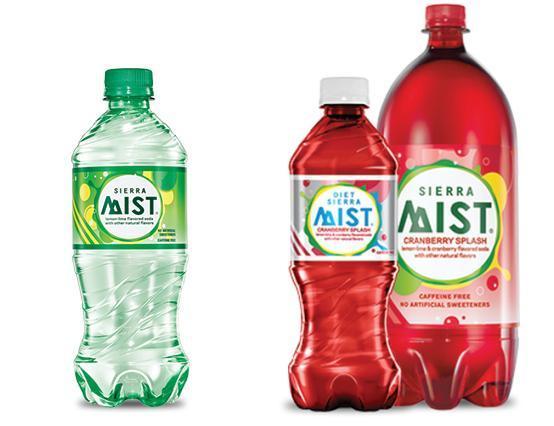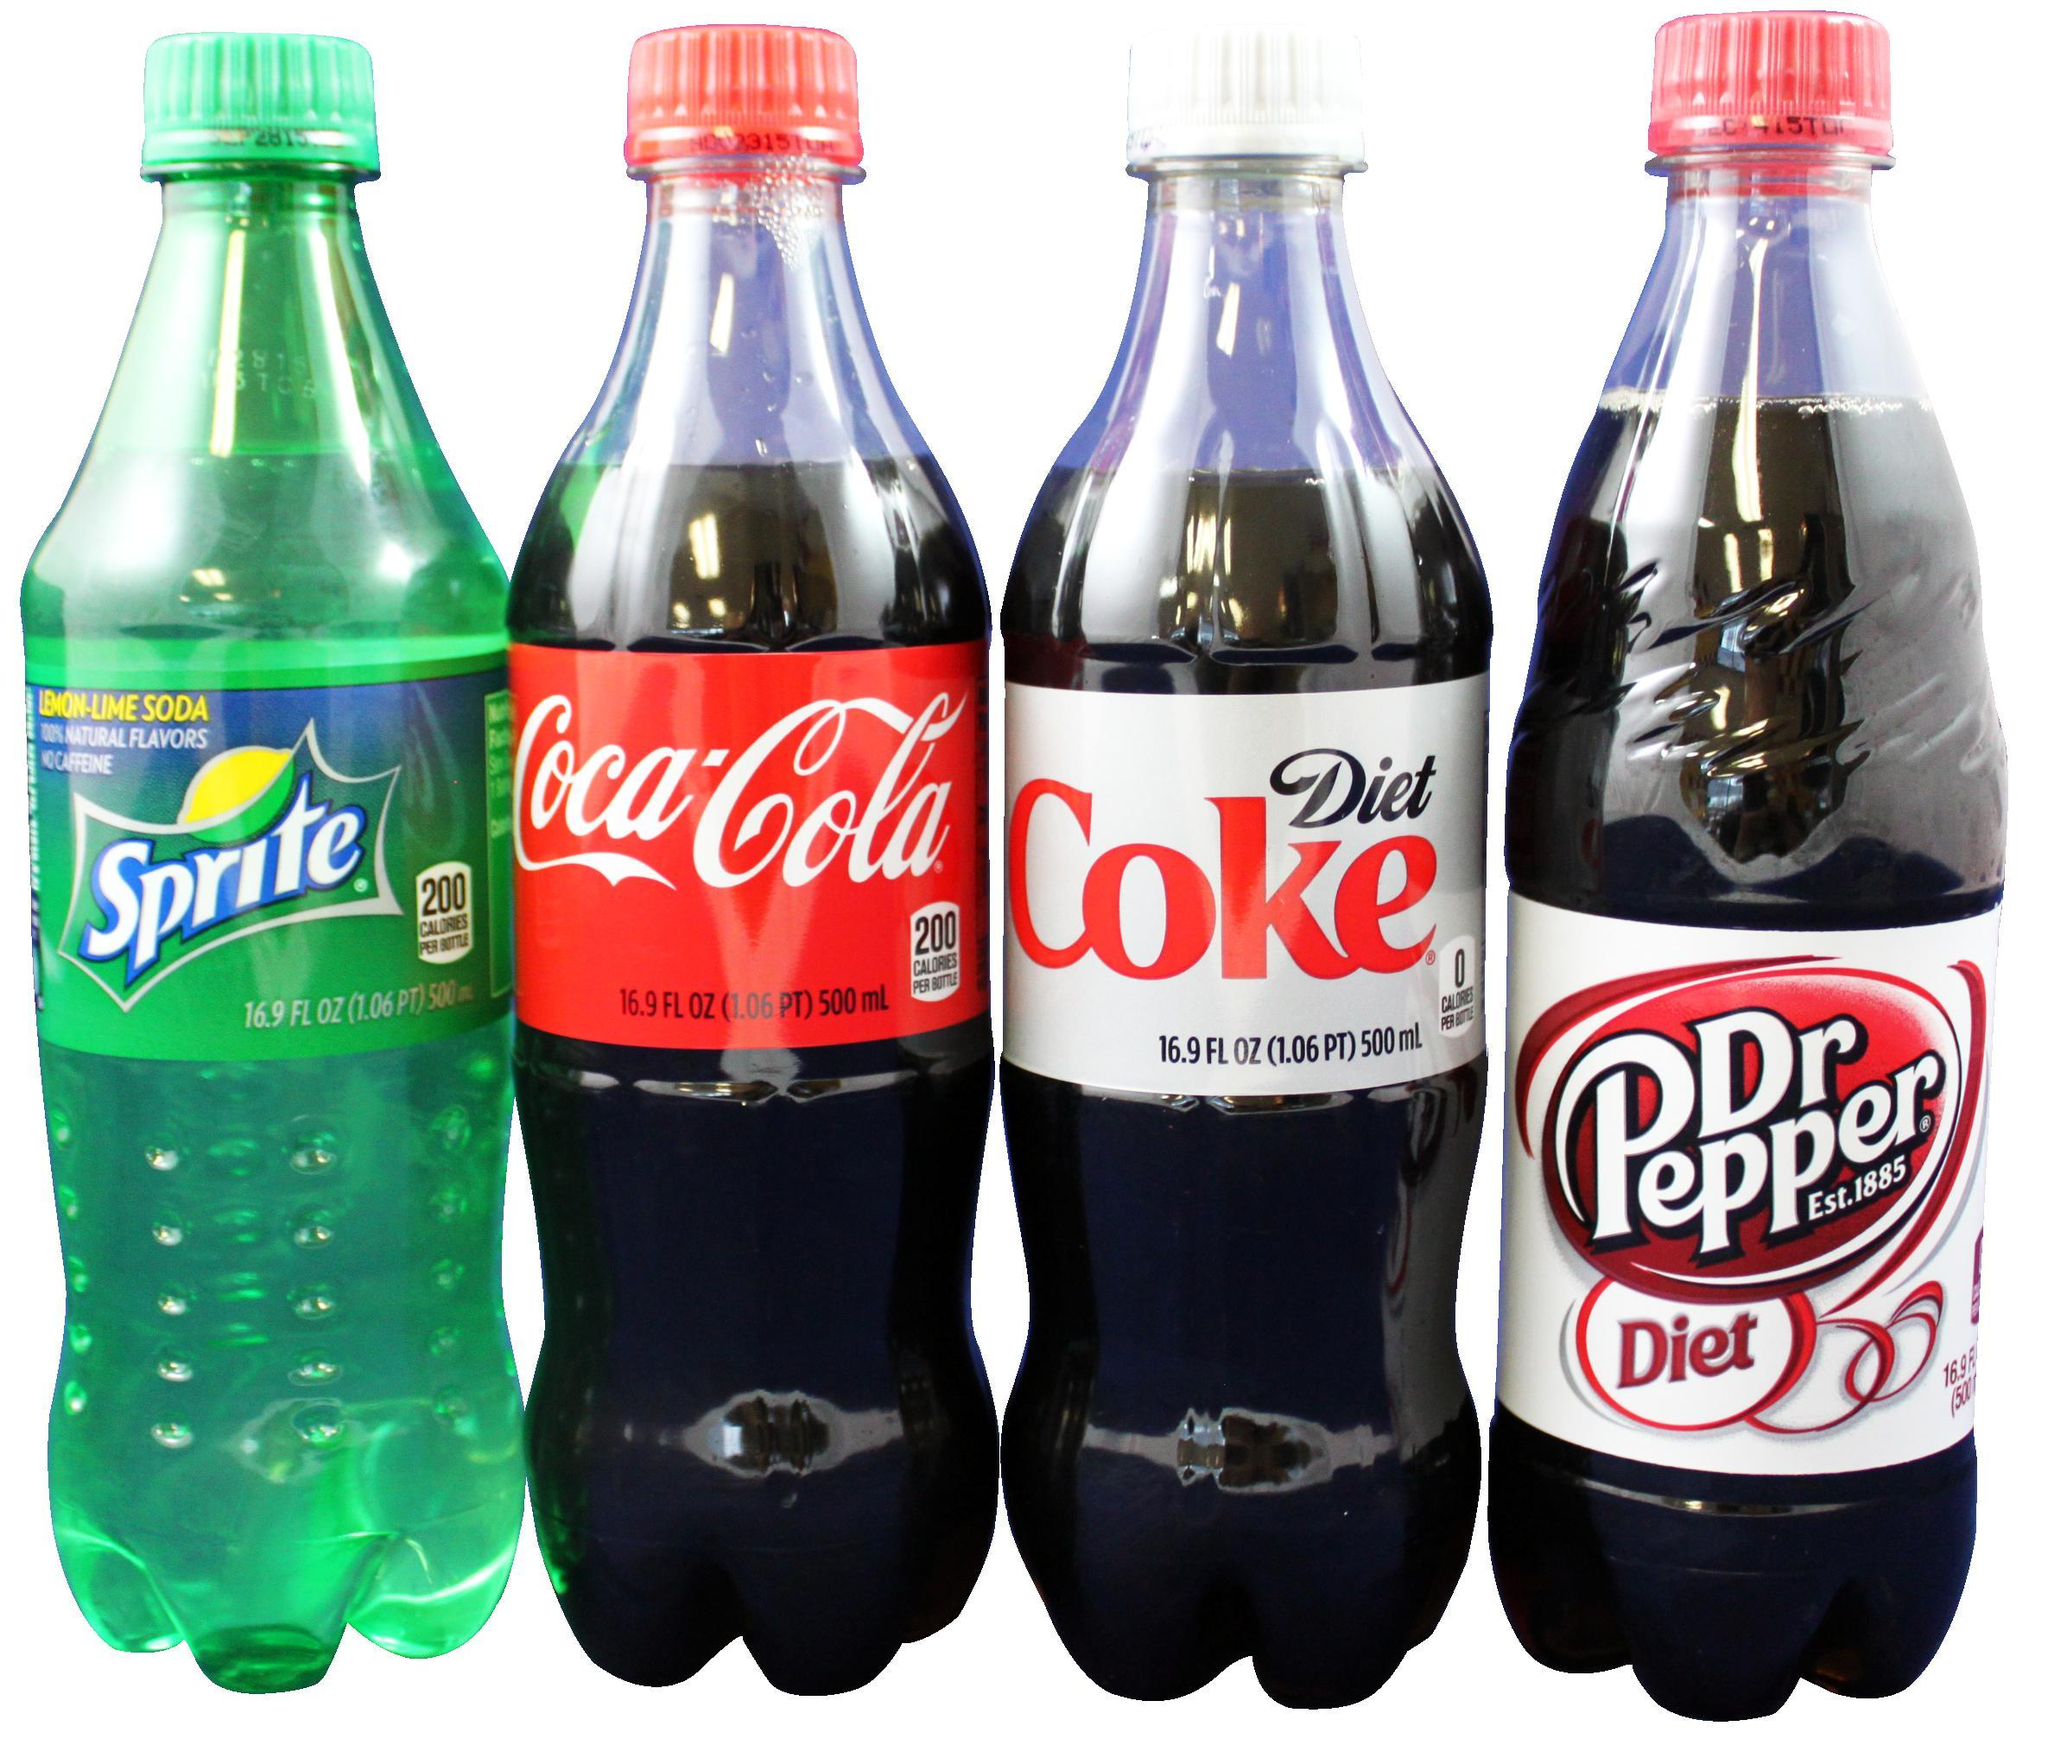The first image is the image on the left, the second image is the image on the right. Examine the images to the left and right. Is the description "The combined images contain seven soda bottles, and no two bottles are exactly the same." accurate? Answer yes or no. Yes. The first image is the image on the left, the second image is the image on the right. For the images displayed, is the sentence "All sodas in the left image have caffeine." factually correct? Answer yes or no. No. 